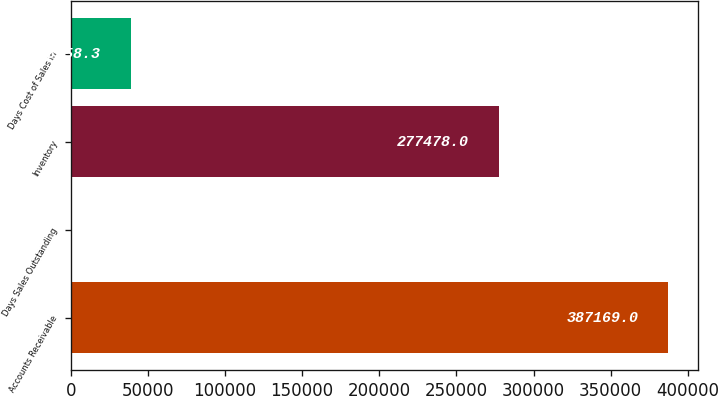Convert chart to OTSL. <chart><loc_0><loc_0><loc_500><loc_500><bar_chart><fcel>Accounts Receivable<fcel>Days Sales Outstanding<fcel>Inventory<fcel>Days Cost of Sales in<nl><fcel>387169<fcel>46<fcel>277478<fcel>38758.3<nl></chart> 